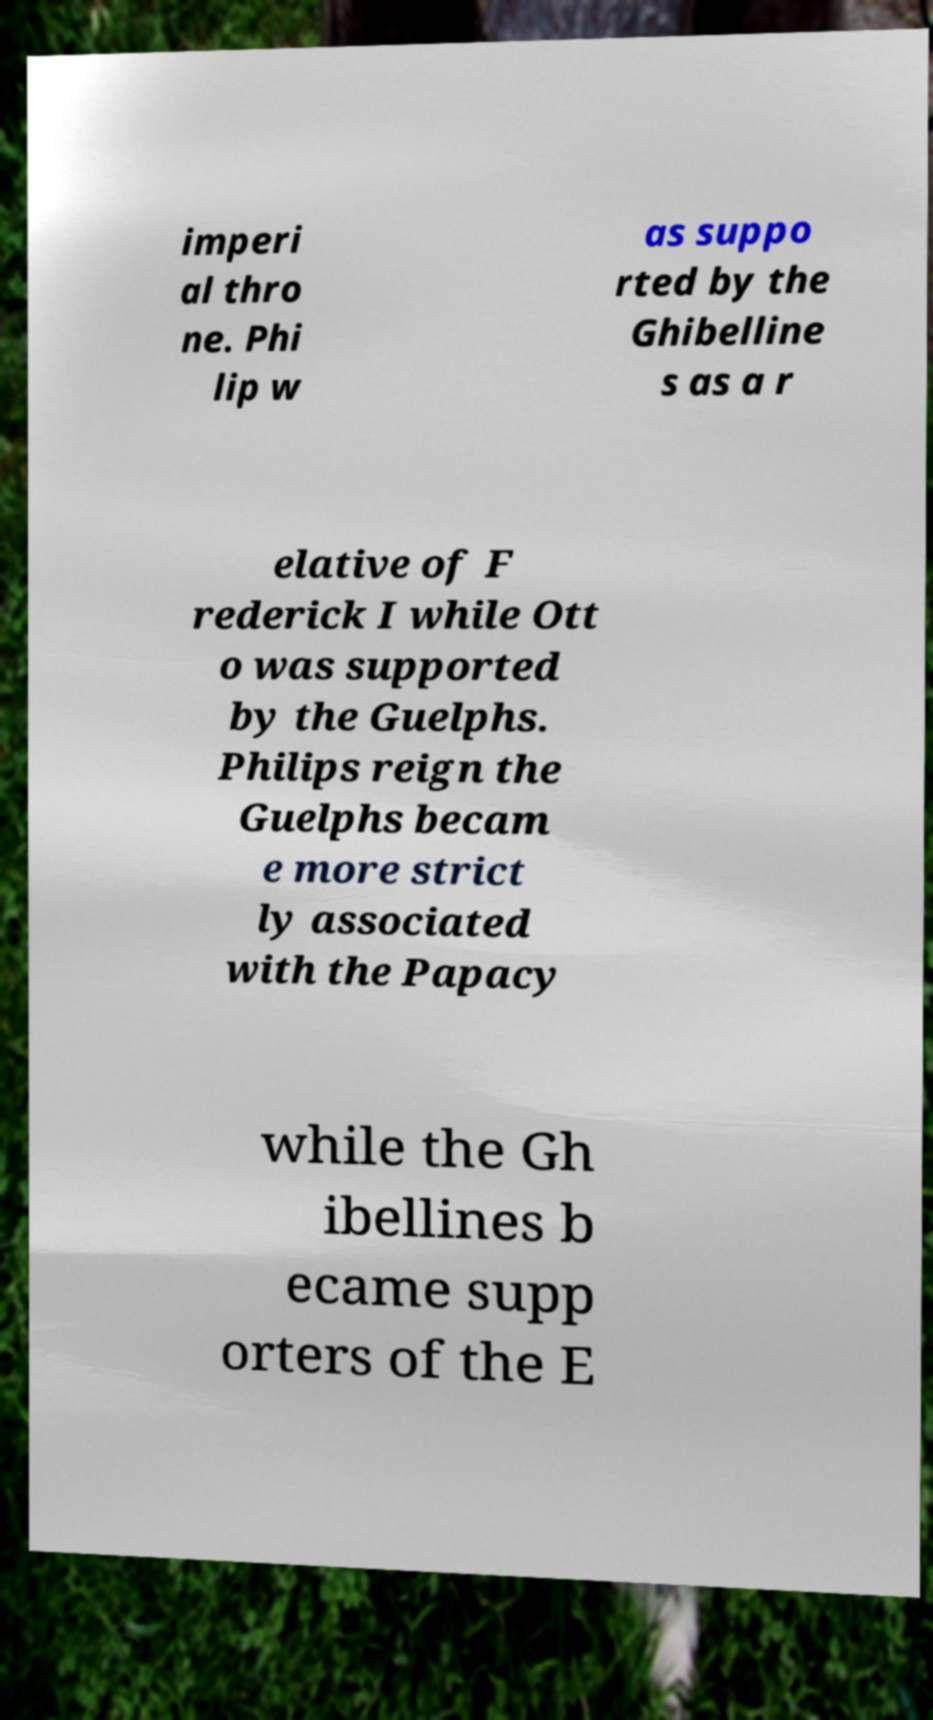Could you assist in decoding the text presented in this image and type it out clearly? imperi al thro ne. Phi lip w as suppo rted by the Ghibelline s as a r elative of F rederick I while Ott o was supported by the Guelphs. Philips reign the Guelphs becam e more strict ly associated with the Papacy while the Gh ibellines b ecame supp orters of the E 